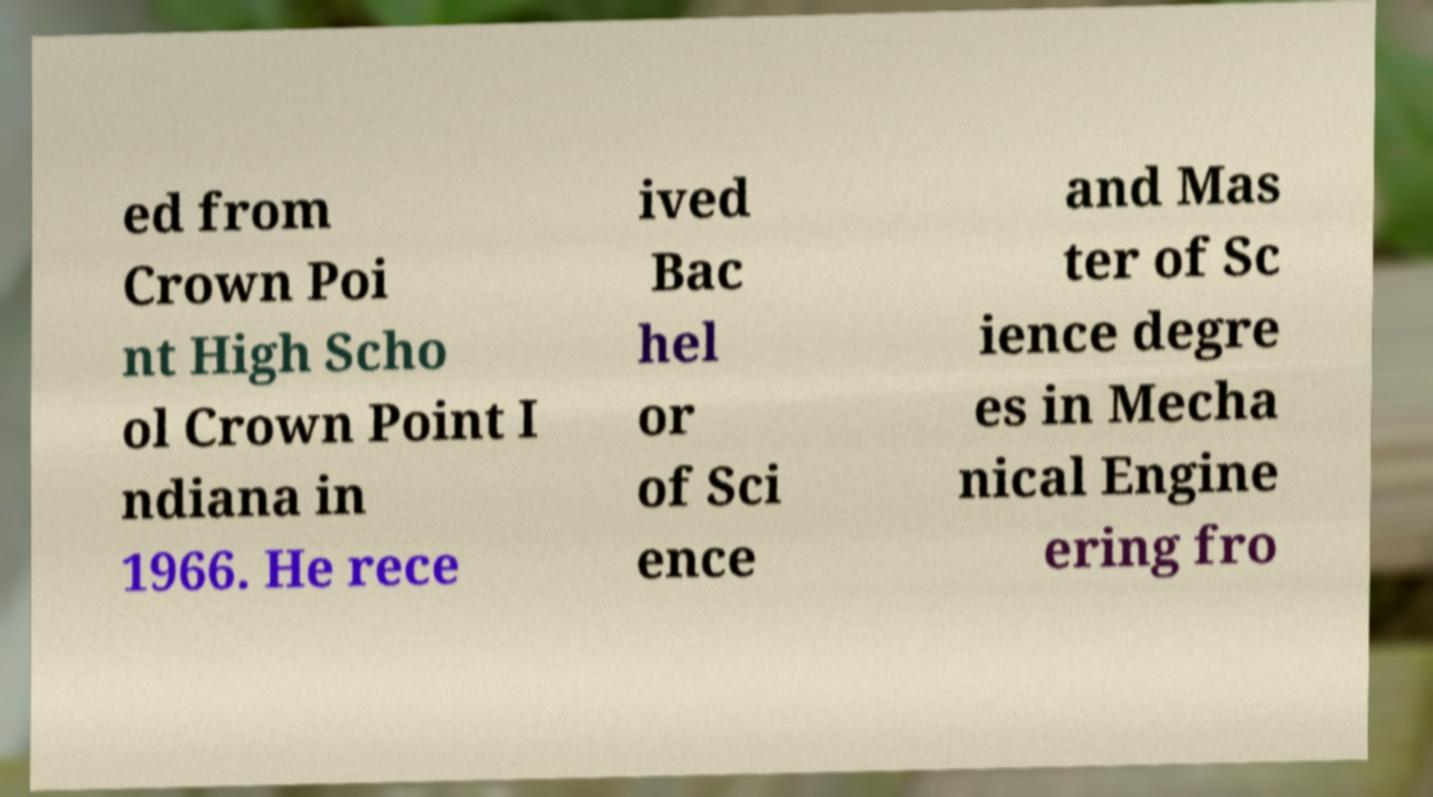Could you assist in decoding the text presented in this image and type it out clearly? ed from Crown Poi nt High Scho ol Crown Point I ndiana in 1966. He rece ived Bac hel or of Sci ence and Mas ter of Sc ience degre es in Mecha nical Engine ering fro 